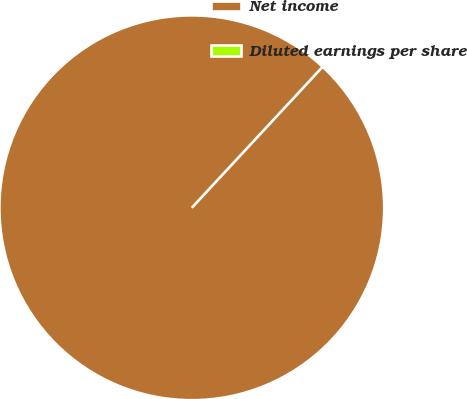Convert chart. <chart><loc_0><loc_0><loc_500><loc_500><pie_chart><fcel>Net income<fcel>Diluted earnings per share<nl><fcel>100.0%<fcel>0.0%<nl></chart> 